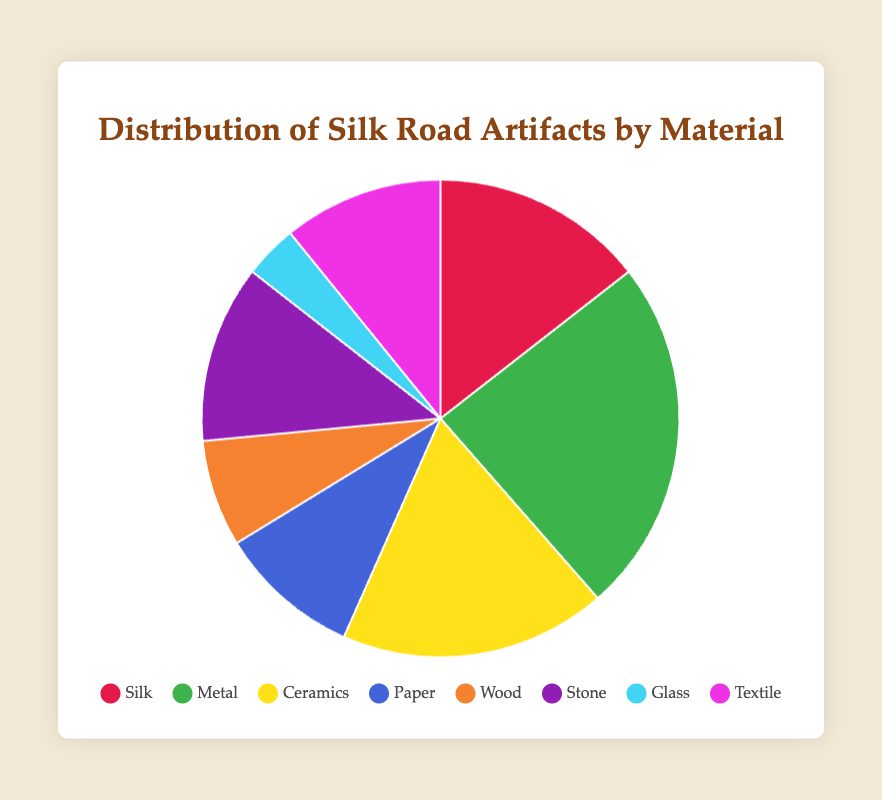What material has the highest count of artifacts? From the pie chart, observe the segmentation and values of the slices. The 'Metal' slice has the highest count, which is 200.
Answer: Metal Which material has the least amount of artifacts? The smallest slice in the pie chart represents 'Glass', with a count of 30 artifacts.
Answer: Glass How many more artifacts of 'Metal' are there compared to 'Glass'? The count for 'Metal' is 200 and for 'Glass' is 30. Subtract the smaller count from the larger count: 200 - 30 = 170.
Answer: 170 Which materials have artifact counts less than 100? Identify slices with counts less than 100: 'Paper' (80), 'Wood' (60), and 'Glass' (30).
Answer: Paper, Wood, Glass What is the total count of artifacts made from 'Ceramics' and 'Stone'? Sum the counts of 'Ceramics' (150) and 'Stone' (100): 150 + 100 = 250.
Answer: 250 What percentage of the artifacts are made from 'Silk'? The 'Silk' slice represents 120 artifacts. Total artifacts are the sum of all counts: 120 + 200 + 150 + 80 + 60 + 100 + 30 + 90 = 830. Silk percentage: (120/830) * 100 ≈ 14.5%.
Answer: 14.5% What is the combined percentage of 'Paper' and 'Wood' artifacts? Combined count for 'Paper' and 'Wood' is 80 + 60 = 140. Total artifact count is 830. Combined percentage: (140/830) * 100 ≈ 16.9%.
Answer: 16.9% Which material's slice of the pie chart is represented in yellow? The slice represented in yellow corresponds to 'Ceramics'.
Answer: Ceramics 